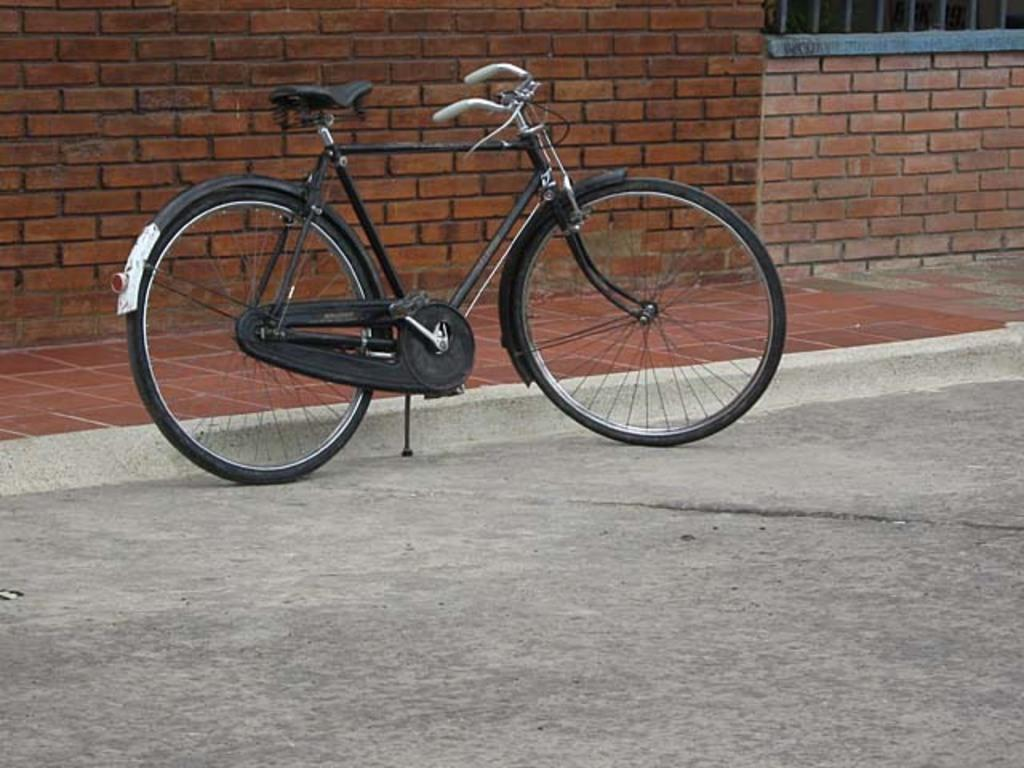What is the main object in the image? There is a bicycle in the image. Where is the bicycle located? The bicycle is on the road. What type of structure is visible in the image? There is a brown color brick wall in the image. How is the brick wall positioned in relation to the bicycle? The brick wall is located to the side of the bicycle. What word can be seen written on the bicycle in the image? There are no words visible on the bicycle in the image. How many fingers are visible on the bicycle in the image? There are no fingers visible on the bicycle in the image. 